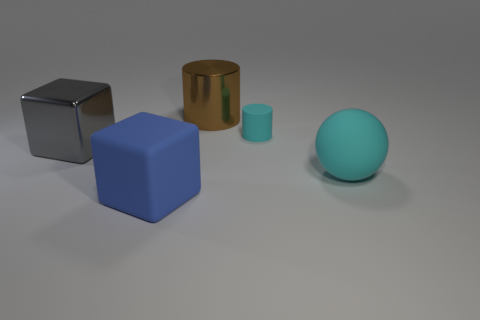Add 2 large cubes. How many objects exist? 7 Subtract all cylinders. How many objects are left? 3 Subtract all brown blocks. How many cyan cylinders are left? 1 Subtract all matte cylinders. Subtract all metallic blocks. How many objects are left? 3 Add 5 tiny things. How many tiny things are left? 6 Add 2 shiny cylinders. How many shiny cylinders exist? 3 Subtract 0 red spheres. How many objects are left? 5 Subtract all red cubes. Subtract all gray balls. How many cubes are left? 2 